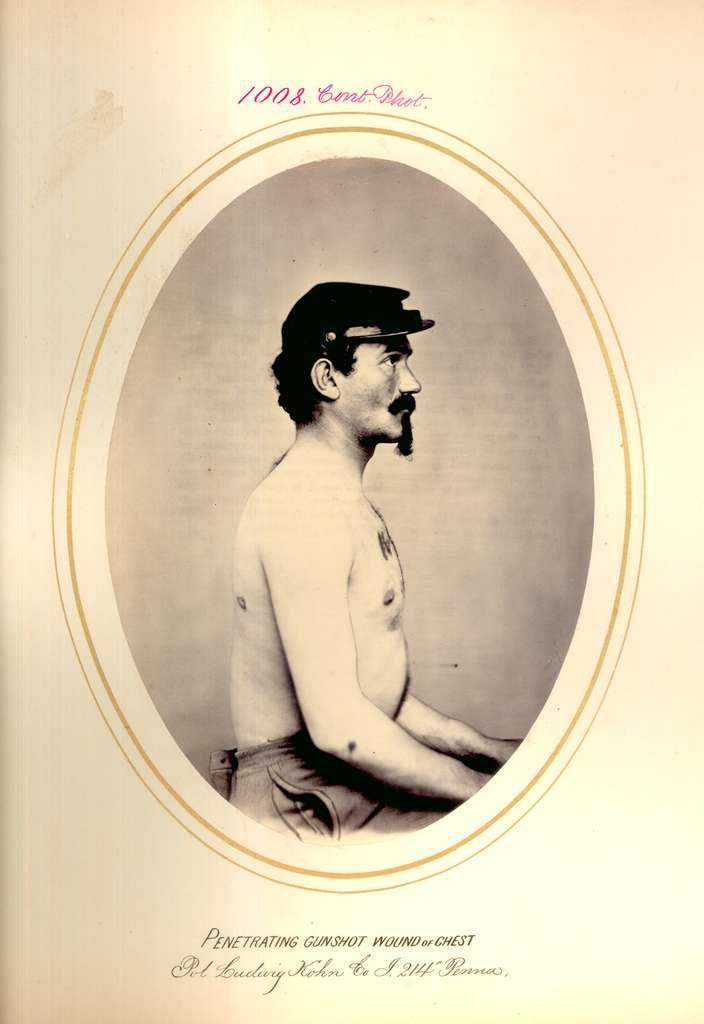Could you give a brief overview of what you see in this image? There is a person facing towards right. He is wearing a cap and a pant. 